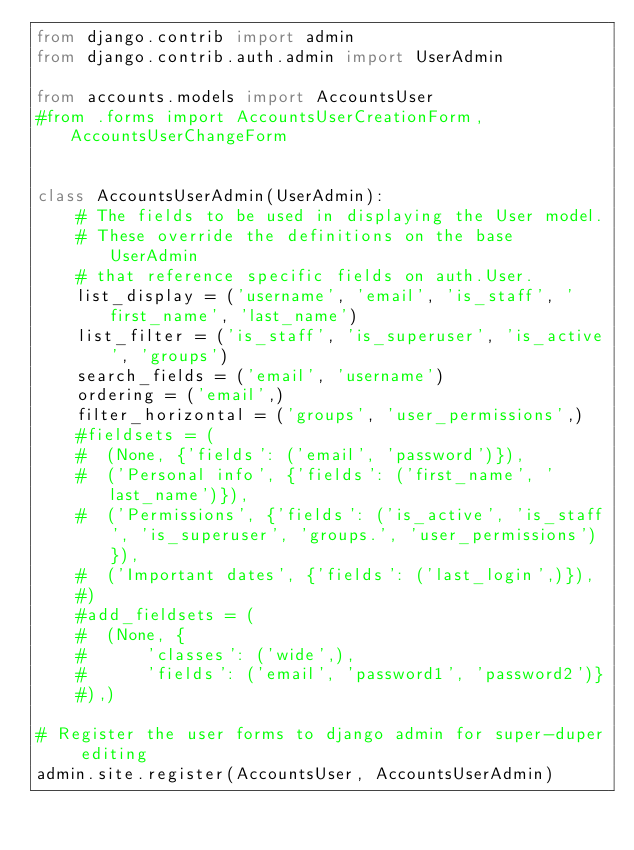<code> <loc_0><loc_0><loc_500><loc_500><_Python_>from django.contrib import admin
from django.contrib.auth.admin import UserAdmin

from accounts.models import AccountsUser
#from .forms import AccountsUserCreationForm, AccountsUserChangeForm


class AccountsUserAdmin(UserAdmin):
    # The fields to be used in displaying the User model.
    # These override the definitions on the base UserAdmin
    # that reference specific fields on auth.User.
    list_display = ('username', 'email', 'is_staff', 'first_name', 'last_name')
    list_filter = ('is_staff', 'is_superuser', 'is_active', 'groups')
    search_fields = ('email', 'username')
    ordering = ('email',)
    filter_horizontal = ('groups', 'user_permissions',)
    #fieldsets = (
    #  (None, {'fields': ('email', 'password')}),
    #  ('Personal info', {'fields': ('first_name', 'last_name')}),
    #  ('Permissions', {'fields': ('is_active', 'is_staff', 'is_superuser', 'groups.', 'user_permissions')}),
    #  ('Important dates', {'fields': ('last_login',)}),
    #)
    #add_fieldsets = (
    #  (None, {
    #      'classes': ('wide',),
    #      'fields': ('email', 'password1', 'password2')}
    #),)

# Register the user forms to django admin for super-duper editing
admin.site.register(AccountsUser, AccountsUserAdmin)
</code> 